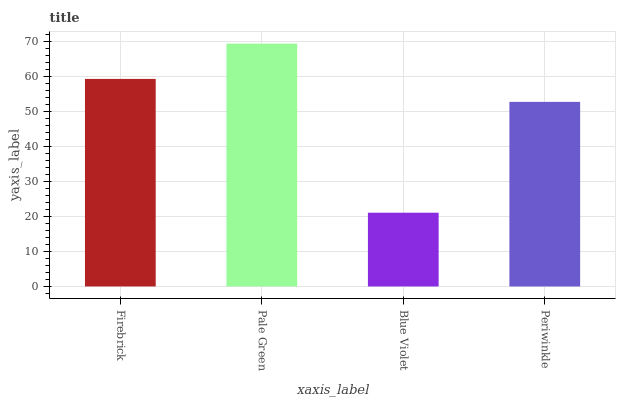Is Blue Violet the minimum?
Answer yes or no. Yes. Is Pale Green the maximum?
Answer yes or no. Yes. Is Pale Green the minimum?
Answer yes or no. No. Is Blue Violet the maximum?
Answer yes or no. No. Is Pale Green greater than Blue Violet?
Answer yes or no. Yes. Is Blue Violet less than Pale Green?
Answer yes or no. Yes. Is Blue Violet greater than Pale Green?
Answer yes or no. No. Is Pale Green less than Blue Violet?
Answer yes or no. No. Is Firebrick the high median?
Answer yes or no. Yes. Is Periwinkle the low median?
Answer yes or no. Yes. Is Periwinkle the high median?
Answer yes or no. No. Is Firebrick the low median?
Answer yes or no. No. 